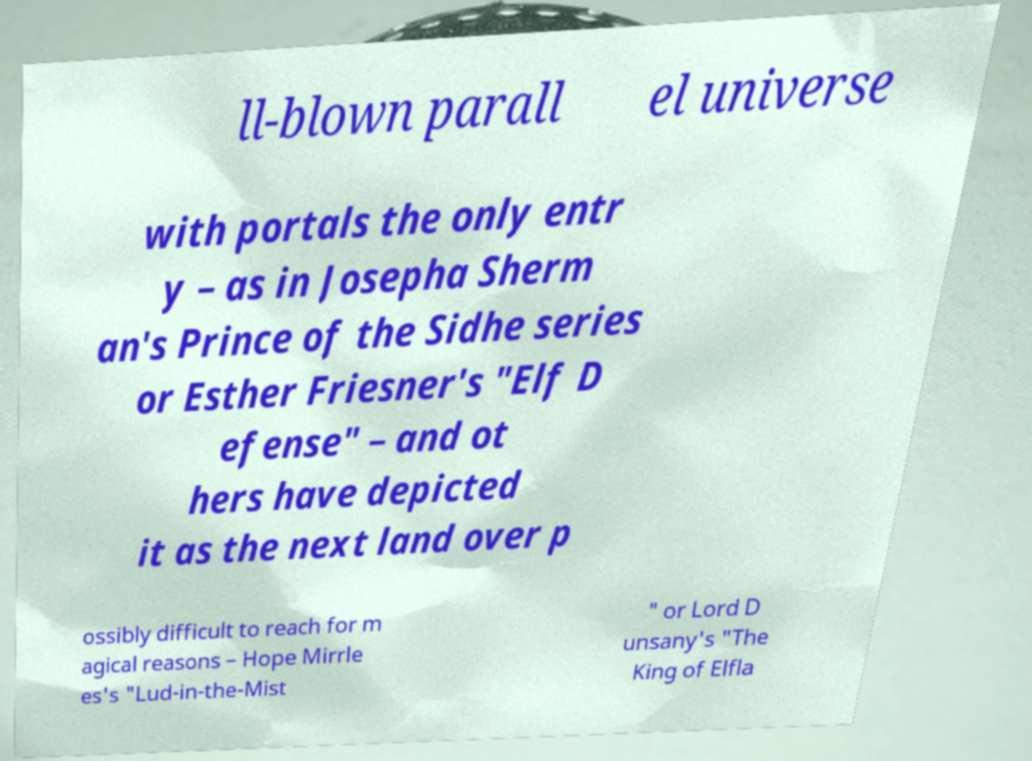Please identify and transcribe the text found in this image. ll-blown parall el universe with portals the only entr y – as in Josepha Sherm an's Prince of the Sidhe series or Esther Friesner's "Elf D efense" – and ot hers have depicted it as the next land over p ossibly difficult to reach for m agical reasons – Hope Mirrle es's "Lud-in-the-Mist " or Lord D unsany's "The King of Elfla 